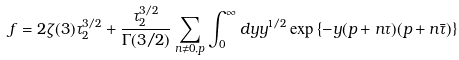<formula> <loc_0><loc_0><loc_500><loc_500>f = 2 \zeta ( 3 ) \tau _ { 2 } ^ { 3 / 2 } + { \frac { \tau _ { 2 } ^ { 3 / 2 } } { \Gamma ( 3 / 2 ) } } \sum _ { n \neq 0 , p } \int _ { 0 } ^ { \infty } d y y ^ { 1 / 2 } \exp \left \{ - y ( p + n \tau ) ( p + n \bar { \tau } ) \right \}</formula> 